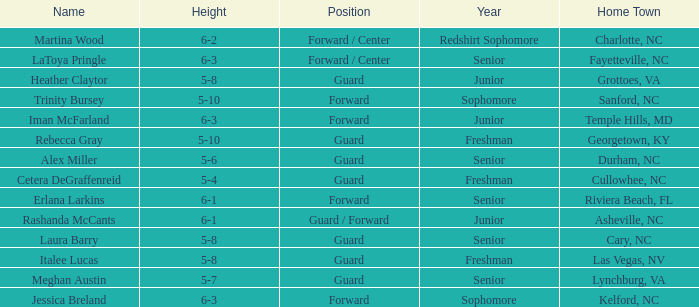How tall is the freshman guard Cetera Degraffenreid? 5-4. 